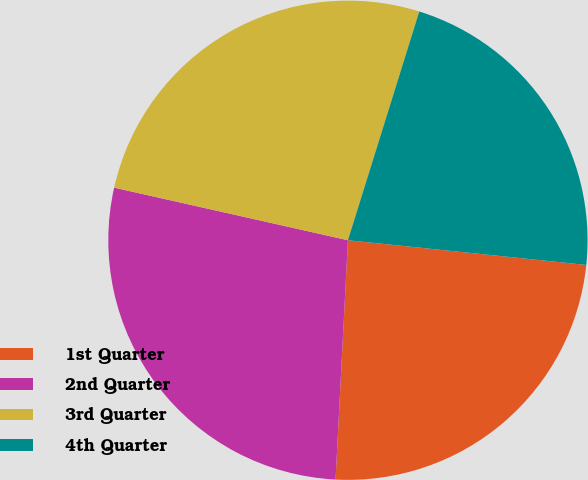Convert chart to OTSL. <chart><loc_0><loc_0><loc_500><loc_500><pie_chart><fcel>1st Quarter<fcel>2nd Quarter<fcel>3rd Quarter<fcel>4th Quarter<nl><fcel>24.18%<fcel>27.7%<fcel>26.29%<fcel>21.83%<nl></chart> 